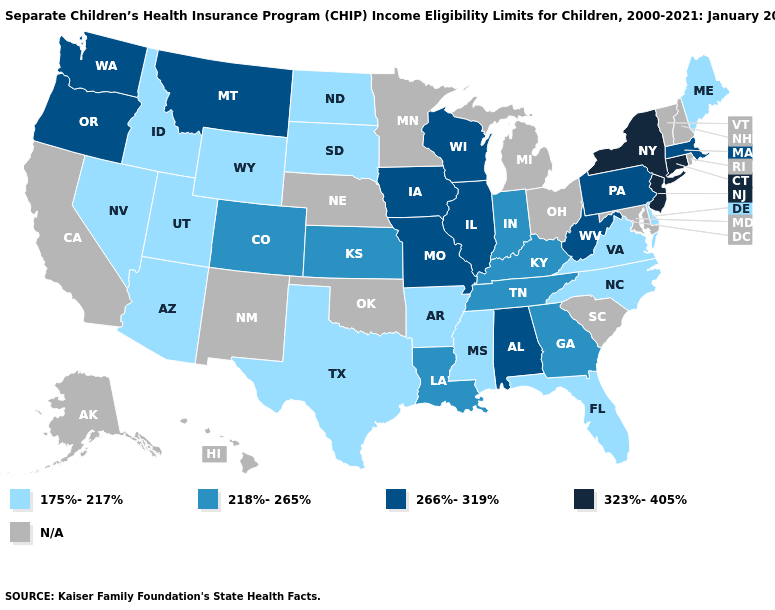Name the states that have a value in the range N/A?
Concise answer only. Alaska, California, Hawaii, Maryland, Michigan, Minnesota, Nebraska, New Hampshire, New Mexico, Ohio, Oklahoma, Rhode Island, South Carolina, Vermont. What is the value of Alaska?
Answer briefly. N/A. What is the value of Colorado?
Answer briefly. 218%-265%. What is the value of Oklahoma?
Keep it brief. N/A. Which states hav the highest value in the MidWest?
Quick response, please. Illinois, Iowa, Missouri, Wisconsin. What is the lowest value in states that border Maryland?
Answer briefly. 175%-217%. Which states have the lowest value in the MidWest?
Short answer required. North Dakota, South Dakota. Name the states that have a value in the range 175%-217%?
Concise answer only. Arizona, Arkansas, Delaware, Florida, Idaho, Maine, Mississippi, Nevada, North Carolina, North Dakota, South Dakota, Texas, Utah, Virginia, Wyoming. Among the states that border Iowa , does South Dakota have the lowest value?
Give a very brief answer. Yes. What is the lowest value in states that border Ohio?
Be succinct. 218%-265%. What is the value of Alaska?
Short answer required. N/A. Name the states that have a value in the range 323%-405%?
Keep it brief. Connecticut, New Jersey, New York. Name the states that have a value in the range 175%-217%?
Be succinct. Arizona, Arkansas, Delaware, Florida, Idaho, Maine, Mississippi, Nevada, North Carolina, North Dakota, South Dakota, Texas, Utah, Virginia, Wyoming. 